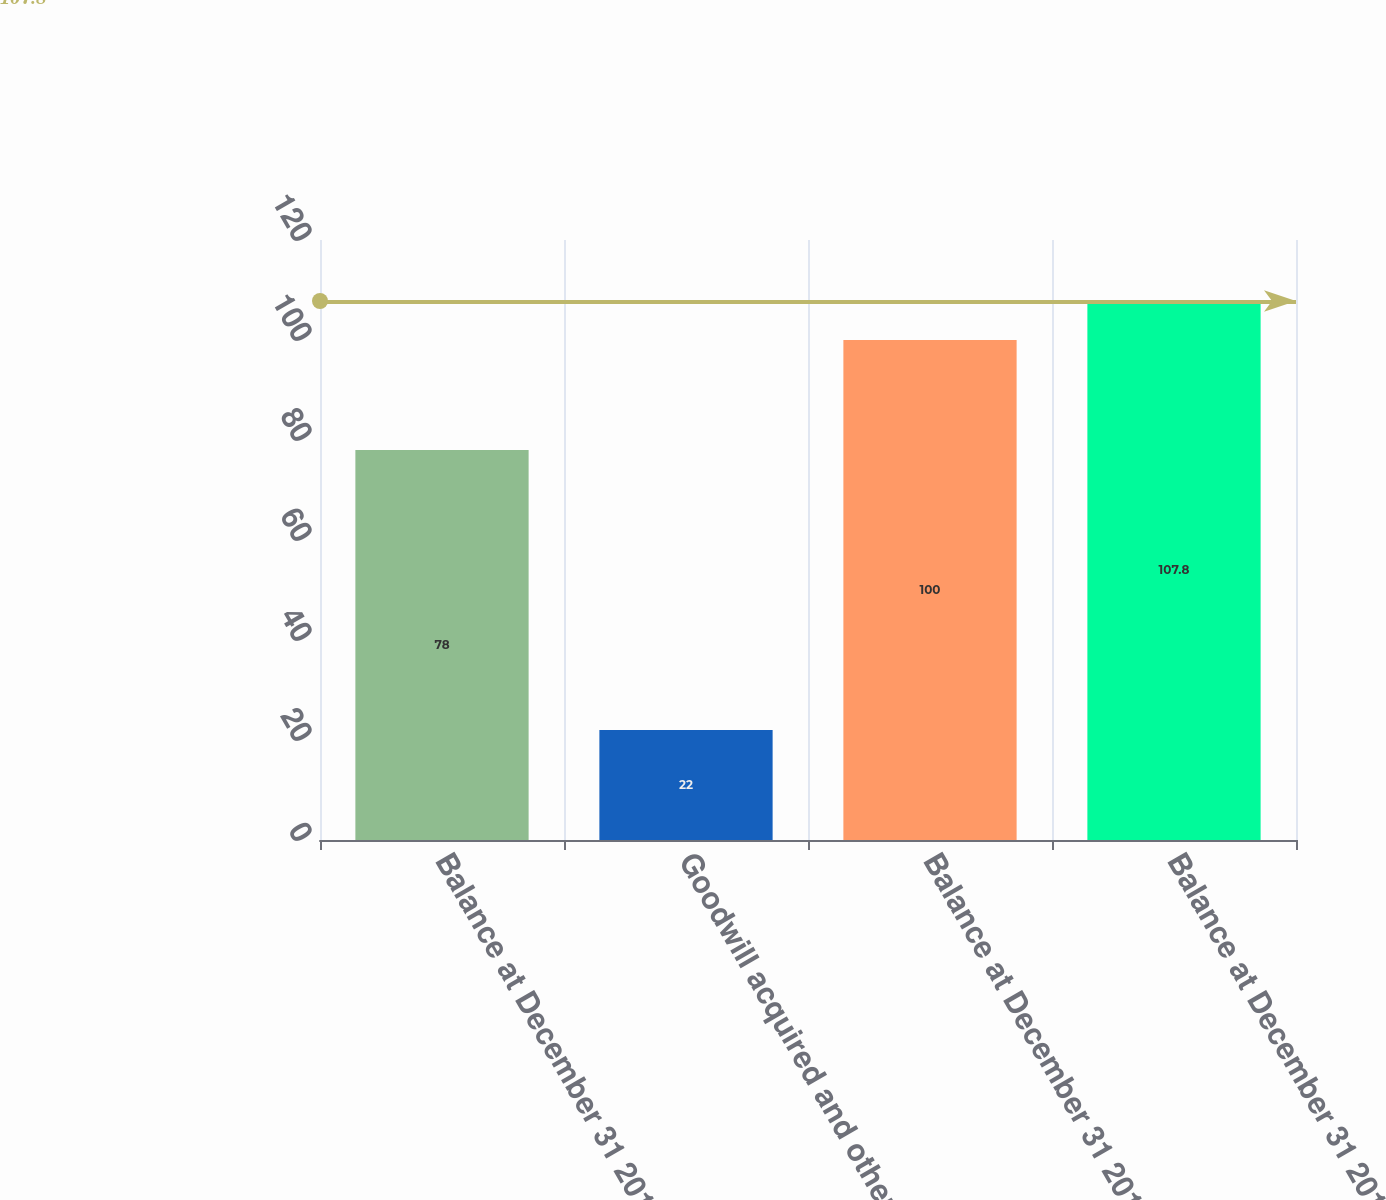Convert chart. <chart><loc_0><loc_0><loc_500><loc_500><bar_chart><fcel>Balance at December 31 2011<fcel>Goodwill acquired and other<fcel>Balance at December 31 2012<fcel>Balance at December 31 2013<nl><fcel>78<fcel>22<fcel>100<fcel>107.8<nl></chart> 